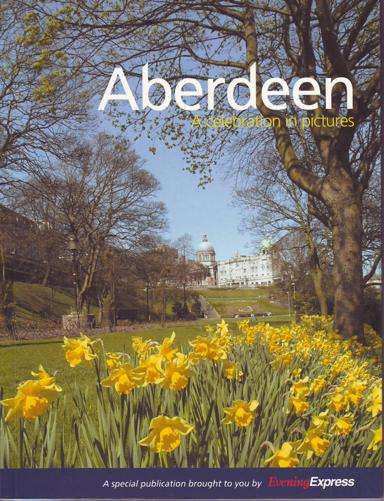Can you tell me more about the kind of flora displayed in the foreground of the image? The image prominently features a beautiful display of yellow daffodils, which are commonly associated with the onset of spring. These flowers are especially plentiful in Aberdeen during the spring months, adding vibrant bursts of color across the city's parks and gardens. Their presence in the image highlights the city’s natural beauty during this flourishing season. 